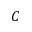<formula> <loc_0><loc_0><loc_500><loc_500>C</formula> 